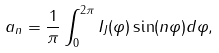<formula> <loc_0><loc_0><loc_500><loc_500>a _ { n } = \frac { 1 } { \pi } \int _ { 0 } ^ { 2 \pi } I _ { J } ( \varphi ) \sin ( n \varphi ) d \varphi ,</formula> 